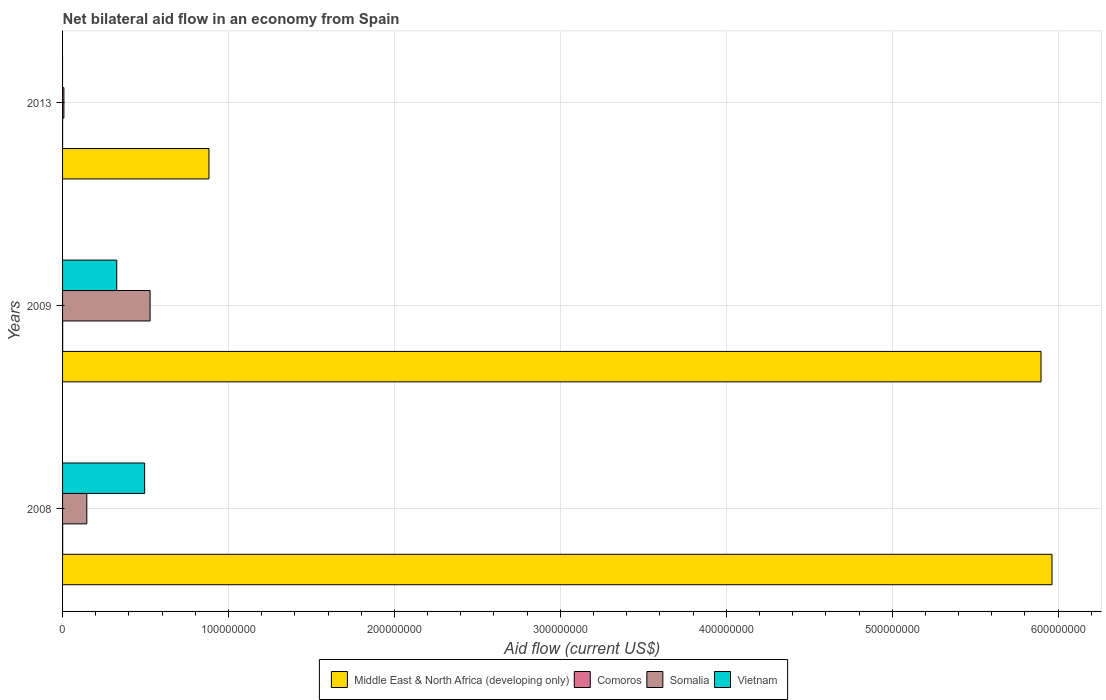How many different coloured bars are there?
Make the answer very short. 4. Are the number of bars per tick equal to the number of legend labels?
Keep it short and to the point. No. Are the number of bars on each tick of the Y-axis equal?
Offer a terse response. No. How many bars are there on the 1st tick from the bottom?
Offer a terse response. 4. In how many cases, is the number of bars for a given year not equal to the number of legend labels?
Your answer should be very brief. 1. What is the net bilateral aid flow in Somalia in 2009?
Make the answer very short. 5.28e+07. Across all years, what is the maximum net bilateral aid flow in Middle East & North Africa (developing only)?
Offer a terse response. 5.96e+08. Across all years, what is the minimum net bilateral aid flow in Comoros?
Keep it short and to the point. 10000. In which year was the net bilateral aid flow in Vietnam maximum?
Offer a terse response. 2008. What is the total net bilateral aid flow in Middle East & North Africa (developing only) in the graph?
Give a very brief answer. 1.27e+09. What is the difference between the net bilateral aid flow in Somalia in 2008 and that in 2009?
Offer a very short reply. -3.81e+07. What is the difference between the net bilateral aid flow in Somalia in 2009 and the net bilateral aid flow in Comoros in 2008?
Ensure brevity in your answer.  5.27e+07. What is the average net bilateral aid flow in Middle East & North Africa (developing only) per year?
Make the answer very short. 4.25e+08. In the year 2009, what is the difference between the net bilateral aid flow in Vietnam and net bilateral aid flow in Somalia?
Make the answer very short. -2.01e+07. What is the ratio of the net bilateral aid flow in Somalia in 2008 to that in 2009?
Keep it short and to the point. 0.28. Is the net bilateral aid flow in Middle East & North Africa (developing only) in 2008 less than that in 2013?
Ensure brevity in your answer.  No. Is the difference between the net bilateral aid flow in Vietnam in 2008 and 2009 greater than the difference between the net bilateral aid flow in Somalia in 2008 and 2009?
Your answer should be very brief. Yes. What is the difference between the highest and the second highest net bilateral aid flow in Somalia?
Provide a succinct answer. 3.81e+07. What is the difference between the highest and the lowest net bilateral aid flow in Vietnam?
Provide a short and direct response. 4.95e+07. Is it the case that in every year, the sum of the net bilateral aid flow in Somalia and net bilateral aid flow in Vietnam is greater than the sum of net bilateral aid flow in Comoros and net bilateral aid flow in Middle East & North Africa (developing only)?
Offer a terse response. No. Is it the case that in every year, the sum of the net bilateral aid flow in Vietnam and net bilateral aid flow in Comoros is greater than the net bilateral aid flow in Middle East & North Africa (developing only)?
Provide a short and direct response. No. How many bars are there?
Provide a short and direct response. 11. Are all the bars in the graph horizontal?
Your response must be concise. Yes. How many years are there in the graph?
Your response must be concise. 3. Does the graph contain any zero values?
Provide a succinct answer. Yes. Does the graph contain grids?
Your answer should be very brief. Yes. What is the title of the graph?
Provide a short and direct response. Net bilateral aid flow in an economy from Spain. Does "Tonga" appear as one of the legend labels in the graph?
Ensure brevity in your answer.  No. What is the Aid flow (current US$) in Middle East & North Africa (developing only) in 2008?
Keep it short and to the point. 5.96e+08. What is the Aid flow (current US$) of Somalia in 2008?
Give a very brief answer. 1.46e+07. What is the Aid flow (current US$) in Vietnam in 2008?
Your response must be concise. 4.95e+07. What is the Aid flow (current US$) in Middle East & North Africa (developing only) in 2009?
Make the answer very short. 5.90e+08. What is the Aid flow (current US$) of Comoros in 2009?
Ensure brevity in your answer.  5.00e+04. What is the Aid flow (current US$) in Somalia in 2009?
Ensure brevity in your answer.  5.28e+07. What is the Aid flow (current US$) in Vietnam in 2009?
Your answer should be compact. 3.26e+07. What is the Aid flow (current US$) of Middle East & North Africa (developing only) in 2013?
Make the answer very short. 8.82e+07. What is the Aid flow (current US$) in Somalia in 2013?
Offer a very short reply. 8.10e+05. What is the Aid flow (current US$) of Vietnam in 2013?
Offer a very short reply. 0. Across all years, what is the maximum Aid flow (current US$) in Middle East & North Africa (developing only)?
Your response must be concise. 5.96e+08. Across all years, what is the maximum Aid flow (current US$) in Comoros?
Your answer should be compact. 5.00e+04. Across all years, what is the maximum Aid flow (current US$) in Somalia?
Provide a short and direct response. 5.28e+07. Across all years, what is the maximum Aid flow (current US$) in Vietnam?
Provide a succinct answer. 4.95e+07. Across all years, what is the minimum Aid flow (current US$) of Middle East & North Africa (developing only)?
Provide a succinct answer. 8.82e+07. Across all years, what is the minimum Aid flow (current US$) in Comoros?
Your response must be concise. 10000. Across all years, what is the minimum Aid flow (current US$) in Somalia?
Give a very brief answer. 8.10e+05. Across all years, what is the minimum Aid flow (current US$) of Vietnam?
Offer a terse response. 0. What is the total Aid flow (current US$) in Middle East & North Africa (developing only) in the graph?
Give a very brief answer. 1.27e+09. What is the total Aid flow (current US$) of Comoros in the graph?
Your answer should be very brief. 1.10e+05. What is the total Aid flow (current US$) of Somalia in the graph?
Your answer should be compact. 6.82e+07. What is the total Aid flow (current US$) in Vietnam in the graph?
Provide a short and direct response. 8.21e+07. What is the difference between the Aid flow (current US$) of Middle East & North Africa (developing only) in 2008 and that in 2009?
Your answer should be very brief. 6.62e+06. What is the difference between the Aid flow (current US$) in Comoros in 2008 and that in 2009?
Ensure brevity in your answer.  0. What is the difference between the Aid flow (current US$) in Somalia in 2008 and that in 2009?
Make the answer very short. -3.81e+07. What is the difference between the Aid flow (current US$) in Vietnam in 2008 and that in 2009?
Offer a very short reply. 1.68e+07. What is the difference between the Aid flow (current US$) in Middle East & North Africa (developing only) in 2008 and that in 2013?
Keep it short and to the point. 5.08e+08. What is the difference between the Aid flow (current US$) of Comoros in 2008 and that in 2013?
Offer a terse response. 4.00e+04. What is the difference between the Aid flow (current US$) in Somalia in 2008 and that in 2013?
Your response must be concise. 1.38e+07. What is the difference between the Aid flow (current US$) of Middle East & North Africa (developing only) in 2009 and that in 2013?
Ensure brevity in your answer.  5.01e+08. What is the difference between the Aid flow (current US$) of Somalia in 2009 and that in 2013?
Ensure brevity in your answer.  5.19e+07. What is the difference between the Aid flow (current US$) in Middle East & North Africa (developing only) in 2008 and the Aid flow (current US$) in Comoros in 2009?
Provide a succinct answer. 5.96e+08. What is the difference between the Aid flow (current US$) in Middle East & North Africa (developing only) in 2008 and the Aid flow (current US$) in Somalia in 2009?
Offer a very short reply. 5.44e+08. What is the difference between the Aid flow (current US$) in Middle East & North Africa (developing only) in 2008 and the Aid flow (current US$) in Vietnam in 2009?
Provide a succinct answer. 5.64e+08. What is the difference between the Aid flow (current US$) of Comoros in 2008 and the Aid flow (current US$) of Somalia in 2009?
Give a very brief answer. -5.27e+07. What is the difference between the Aid flow (current US$) of Comoros in 2008 and the Aid flow (current US$) of Vietnam in 2009?
Provide a succinct answer. -3.26e+07. What is the difference between the Aid flow (current US$) in Somalia in 2008 and the Aid flow (current US$) in Vietnam in 2009?
Provide a short and direct response. -1.80e+07. What is the difference between the Aid flow (current US$) of Middle East & North Africa (developing only) in 2008 and the Aid flow (current US$) of Comoros in 2013?
Your response must be concise. 5.96e+08. What is the difference between the Aid flow (current US$) in Middle East & North Africa (developing only) in 2008 and the Aid flow (current US$) in Somalia in 2013?
Give a very brief answer. 5.96e+08. What is the difference between the Aid flow (current US$) of Comoros in 2008 and the Aid flow (current US$) of Somalia in 2013?
Offer a very short reply. -7.60e+05. What is the difference between the Aid flow (current US$) of Middle East & North Africa (developing only) in 2009 and the Aid flow (current US$) of Comoros in 2013?
Provide a succinct answer. 5.90e+08. What is the difference between the Aid flow (current US$) of Middle East & North Africa (developing only) in 2009 and the Aid flow (current US$) of Somalia in 2013?
Provide a short and direct response. 5.89e+08. What is the difference between the Aid flow (current US$) of Comoros in 2009 and the Aid flow (current US$) of Somalia in 2013?
Your answer should be very brief. -7.60e+05. What is the average Aid flow (current US$) of Middle East & North Africa (developing only) per year?
Your response must be concise. 4.25e+08. What is the average Aid flow (current US$) of Comoros per year?
Your response must be concise. 3.67e+04. What is the average Aid flow (current US$) of Somalia per year?
Your response must be concise. 2.27e+07. What is the average Aid flow (current US$) of Vietnam per year?
Your response must be concise. 2.74e+07. In the year 2008, what is the difference between the Aid flow (current US$) in Middle East & North Africa (developing only) and Aid flow (current US$) in Comoros?
Offer a very short reply. 5.96e+08. In the year 2008, what is the difference between the Aid flow (current US$) of Middle East & North Africa (developing only) and Aid flow (current US$) of Somalia?
Make the answer very short. 5.82e+08. In the year 2008, what is the difference between the Aid flow (current US$) in Middle East & North Africa (developing only) and Aid flow (current US$) in Vietnam?
Offer a terse response. 5.47e+08. In the year 2008, what is the difference between the Aid flow (current US$) in Comoros and Aid flow (current US$) in Somalia?
Provide a short and direct response. -1.46e+07. In the year 2008, what is the difference between the Aid flow (current US$) in Comoros and Aid flow (current US$) in Vietnam?
Provide a short and direct response. -4.94e+07. In the year 2008, what is the difference between the Aid flow (current US$) of Somalia and Aid flow (current US$) of Vietnam?
Your answer should be very brief. -3.49e+07. In the year 2009, what is the difference between the Aid flow (current US$) of Middle East & North Africa (developing only) and Aid flow (current US$) of Comoros?
Keep it short and to the point. 5.90e+08. In the year 2009, what is the difference between the Aid flow (current US$) of Middle East & North Africa (developing only) and Aid flow (current US$) of Somalia?
Offer a terse response. 5.37e+08. In the year 2009, what is the difference between the Aid flow (current US$) in Middle East & North Africa (developing only) and Aid flow (current US$) in Vietnam?
Your answer should be very brief. 5.57e+08. In the year 2009, what is the difference between the Aid flow (current US$) in Comoros and Aid flow (current US$) in Somalia?
Your response must be concise. -5.27e+07. In the year 2009, what is the difference between the Aid flow (current US$) of Comoros and Aid flow (current US$) of Vietnam?
Offer a terse response. -3.26e+07. In the year 2009, what is the difference between the Aid flow (current US$) in Somalia and Aid flow (current US$) in Vietnam?
Provide a short and direct response. 2.01e+07. In the year 2013, what is the difference between the Aid flow (current US$) of Middle East & North Africa (developing only) and Aid flow (current US$) of Comoros?
Provide a succinct answer. 8.82e+07. In the year 2013, what is the difference between the Aid flow (current US$) in Middle East & North Africa (developing only) and Aid flow (current US$) in Somalia?
Offer a very short reply. 8.74e+07. In the year 2013, what is the difference between the Aid flow (current US$) in Comoros and Aid flow (current US$) in Somalia?
Your response must be concise. -8.00e+05. What is the ratio of the Aid flow (current US$) in Middle East & North Africa (developing only) in 2008 to that in 2009?
Offer a terse response. 1.01. What is the ratio of the Aid flow (current US$) in Somalia in 2008 to that in 2009?
Your answer should be very brief. 0.28. What is the ratio of the Aid flow (current US$) of Vietnam in 2008 to that in 2009?
Ensure brevity in your answer.  1.52. What is the ratio of the Aid flow (current US$) of Middle East & North Africa (developing only) in 2008 to that in 2013?
Keep it short and to the point. 6.76. What is the ratio of the Aid flow (current US$) in Comoros in 2008 to that in 2013?
Give a very brief answer. 5. What is the ratio of the Aid flow (current US$) in Somalia in 2008 to that in 2013?
Offer a terse response. 18.04. What is the ratio of the Aid flow (current US$) of Middle East & North Africa (developing only) in 2009 to that in 2013?
Keep it short and to the point. 6.68. What is the ratio of the Aid flow (current US$) in Somalia in 2009 to that in 2013?
Provide a succinct answer. 65.12. What is the difference between the highest and the second highest Aid flow (current US$) in Middle East & North Africa (developing only)?
Provide a short and direct response. 6.62e+06. What is the difference between the highest and the second highest Aid flow (current US$) of Somalia?
Ensure brevity in your answer.  3.81e+07. What is the difference between the highest and the lowest Aid flow (current US$) of Middle East & North Africa (developing only)?
Provide a succinct answer. 5.08e+08. What is the difference between the highest and the lowest Aid flow (current US$) in Somalia?
Keep it short and to the point. 5.19e+07. What is the difference between the highest and the lowest Aid flow (current US$) in Vietnam?
Give a very brief answer. 4.95e+07. 